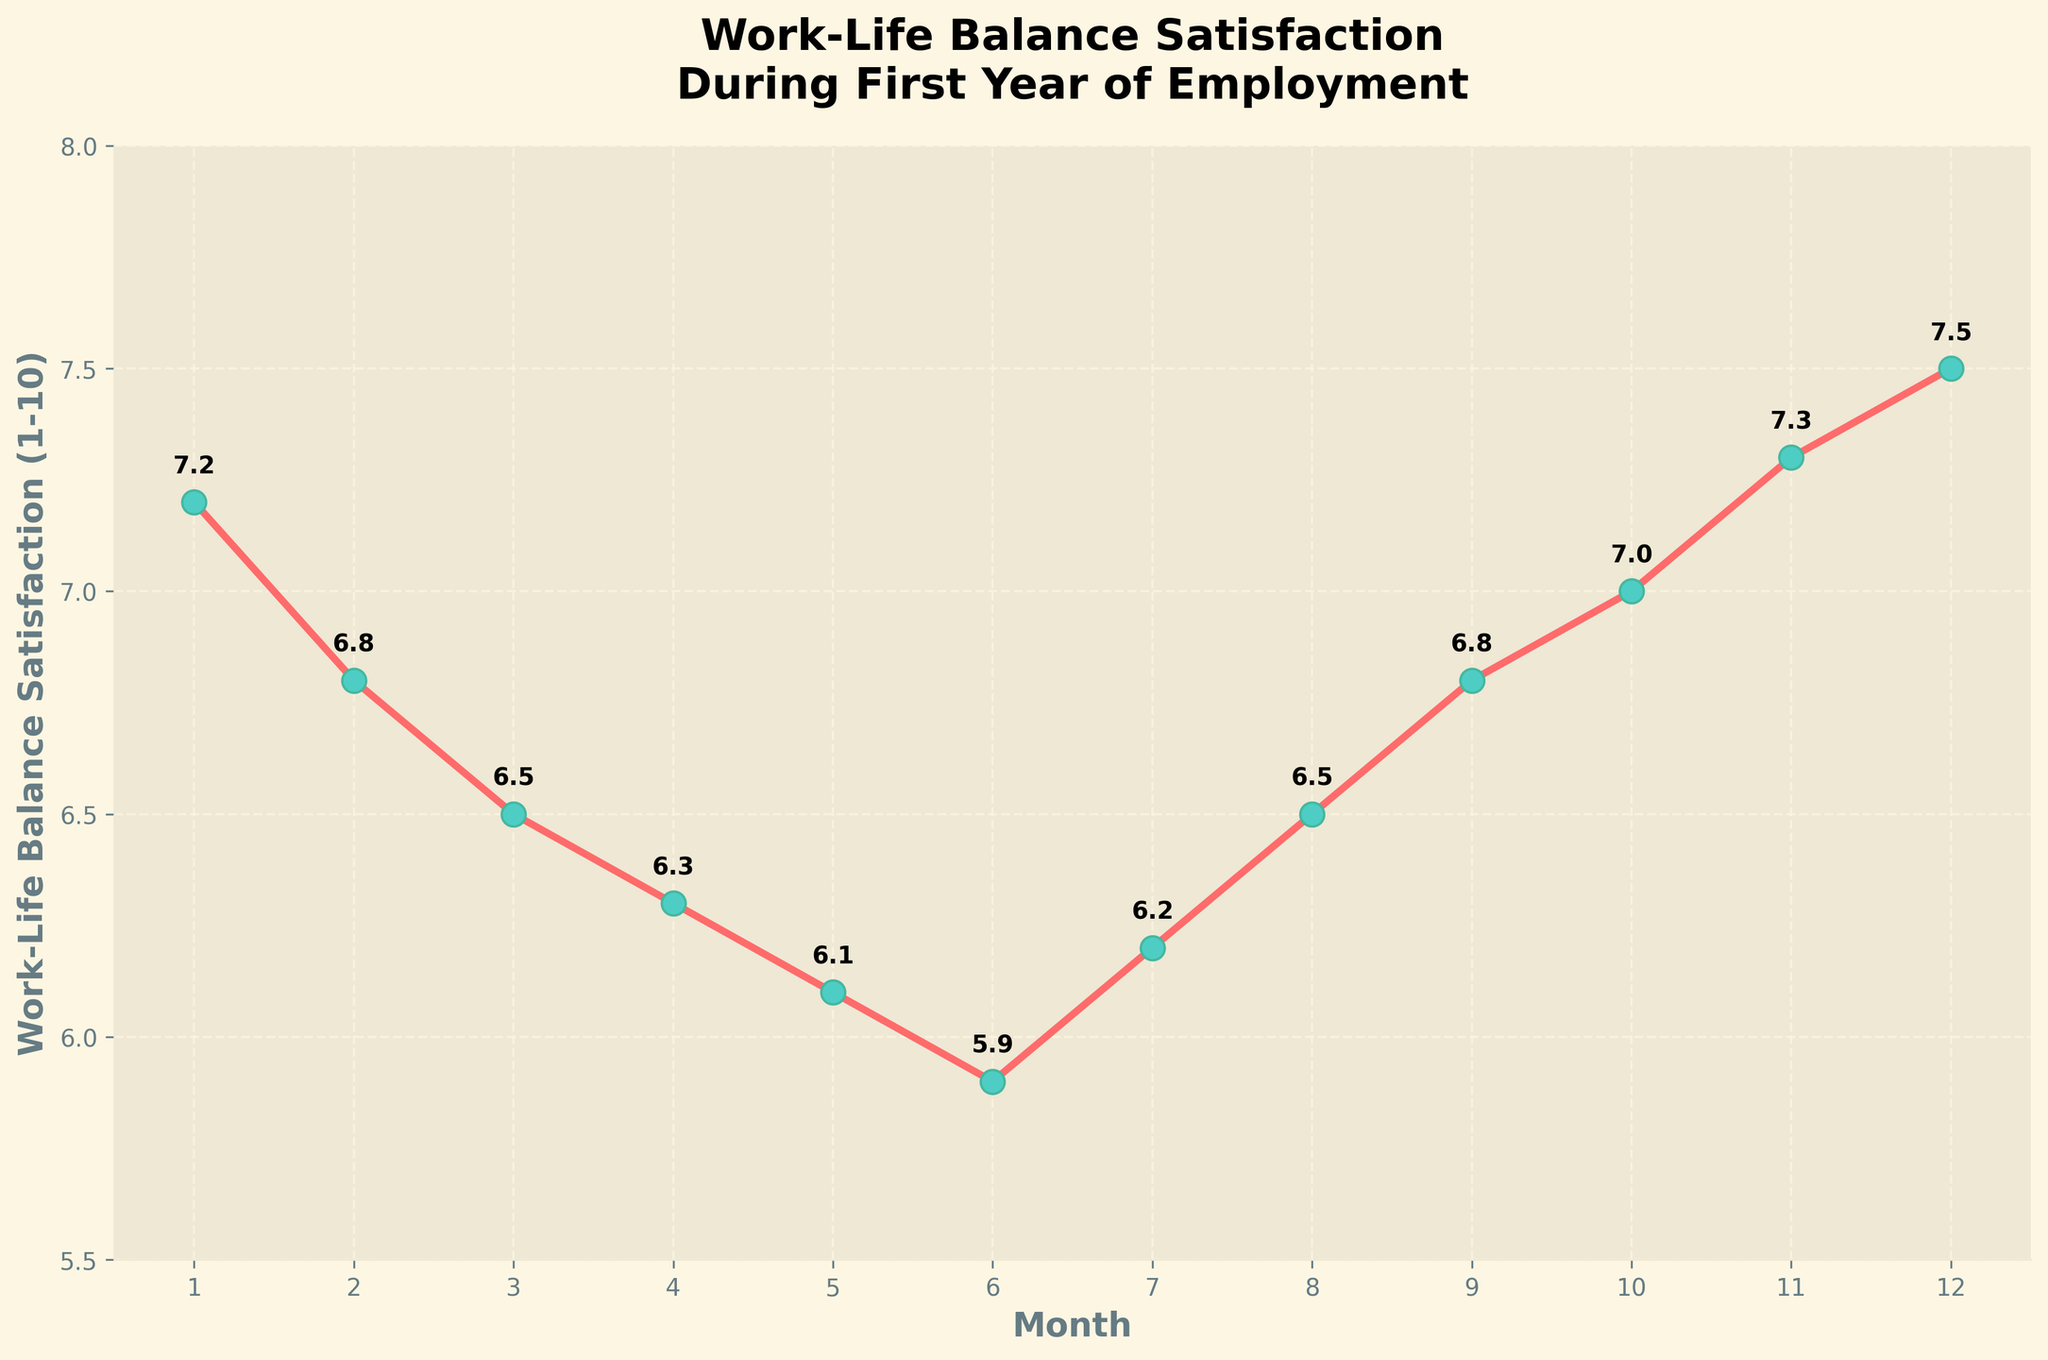What is the trend in work-life balance satisfaction from month 1 to month 6? To see the trend, observe the points from month 1 to month 6. The values consistently decrease from 7.2 (month 1) to 5.9 (month 6), indicating a declining trend.
Answer: Decline What is the lowest work-life balance satisfaction score and in which month does it occur? Identify the minimum value from all the plotted points. The lowest satisfaction score is 5.9, which occurs in month 6.
Answer: 5.9, month 6 In which month does the work-life balance satisfaction return to its initial level as in month 1? Compare values across the months to find when they match the initial value 7.2. Satisfaction returns to 7.2 in month 10.
Answer: Month 10 How does the work-life balance satisfaction change from month 6 to month 12? Observe the values from month 6 (5.9) to month 12 (7.5). The satisfaction score increases steadily from 5.9 to 7.5.
Answer: Increases Which months have a work-life balance satisfaction score equal to or above 7? Identify the months with values ≥ 7. The scores are 7.0 (month 10), 7.3 (month 11), and 7.5 (month 12).
Answer: Months 10, 11, and 12 What is the average work-life balance satisfaction score for the entire year? Sum all satisfaction scores and divide by 12. (7.2+6.8+6.5+6.3+6.1+5.9+6.2+6.5+6.8+7.0+7.3+7.5)/12 = 6.65.
Answer: 6.65 Compare the work-life balance satisfaction in month 3 to month 9. Which is higher? Compare the plotted values for month 3 (6.5) and month 9 (6.8). The value for month 9 is higher.
Answer: Month 9 During which month is the most significant increase in work-life balance satisfaction observed? Compare the differences between consecutive months. The biggest increase is between month 6 (5.9) and month 7 (6.2), which is a 0.3 increase.
Answer: Month 7 